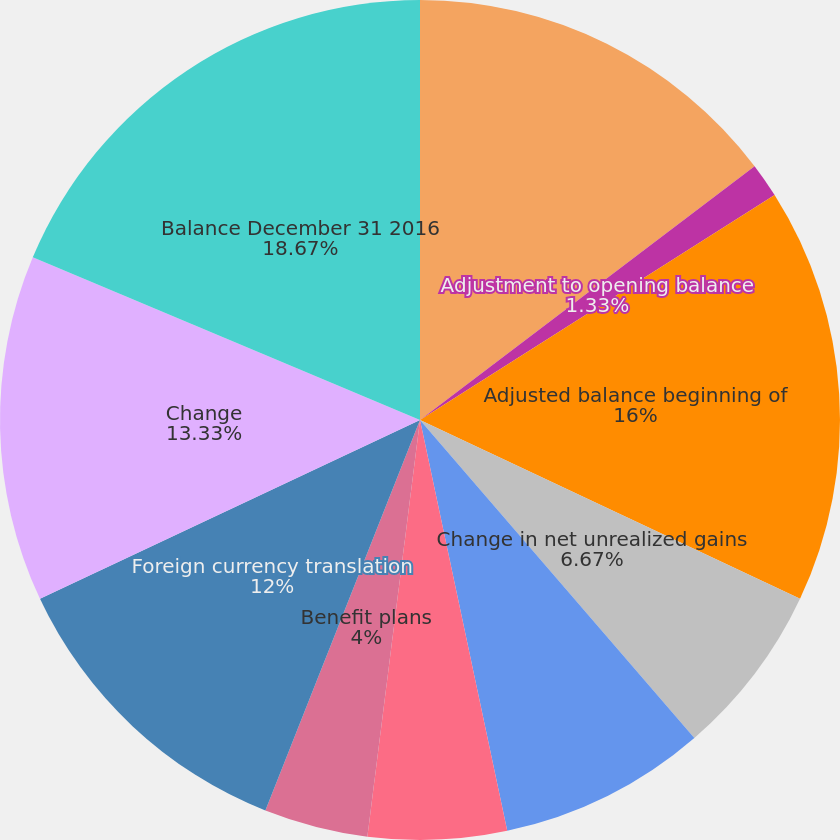Convert chart. <chart><loc_0><loc_0><loc_500><loc_500><pie_chart><fcel>Balance December 31 2015<fcel>Adjustment to opening balance<fcel>Adjusted balance beginning of<fcel>Change in net unrealized gains<fcel>Debt valuation adjustment<fcel>Cash flow hedges<fcel>Benefit plans<fcel>Foreign currency translation<fcel>Change<fcel>Balance December 31 2016<nl><fcel>14.67%<fcel>1.33%<fcel>16.0%<fcel>6.67%<fcel>8.0%<fcel>5.33%<fcel>4.0%<fcel>12.0%<fcel>13.33%<fcel>18.67%<nl></chart> 